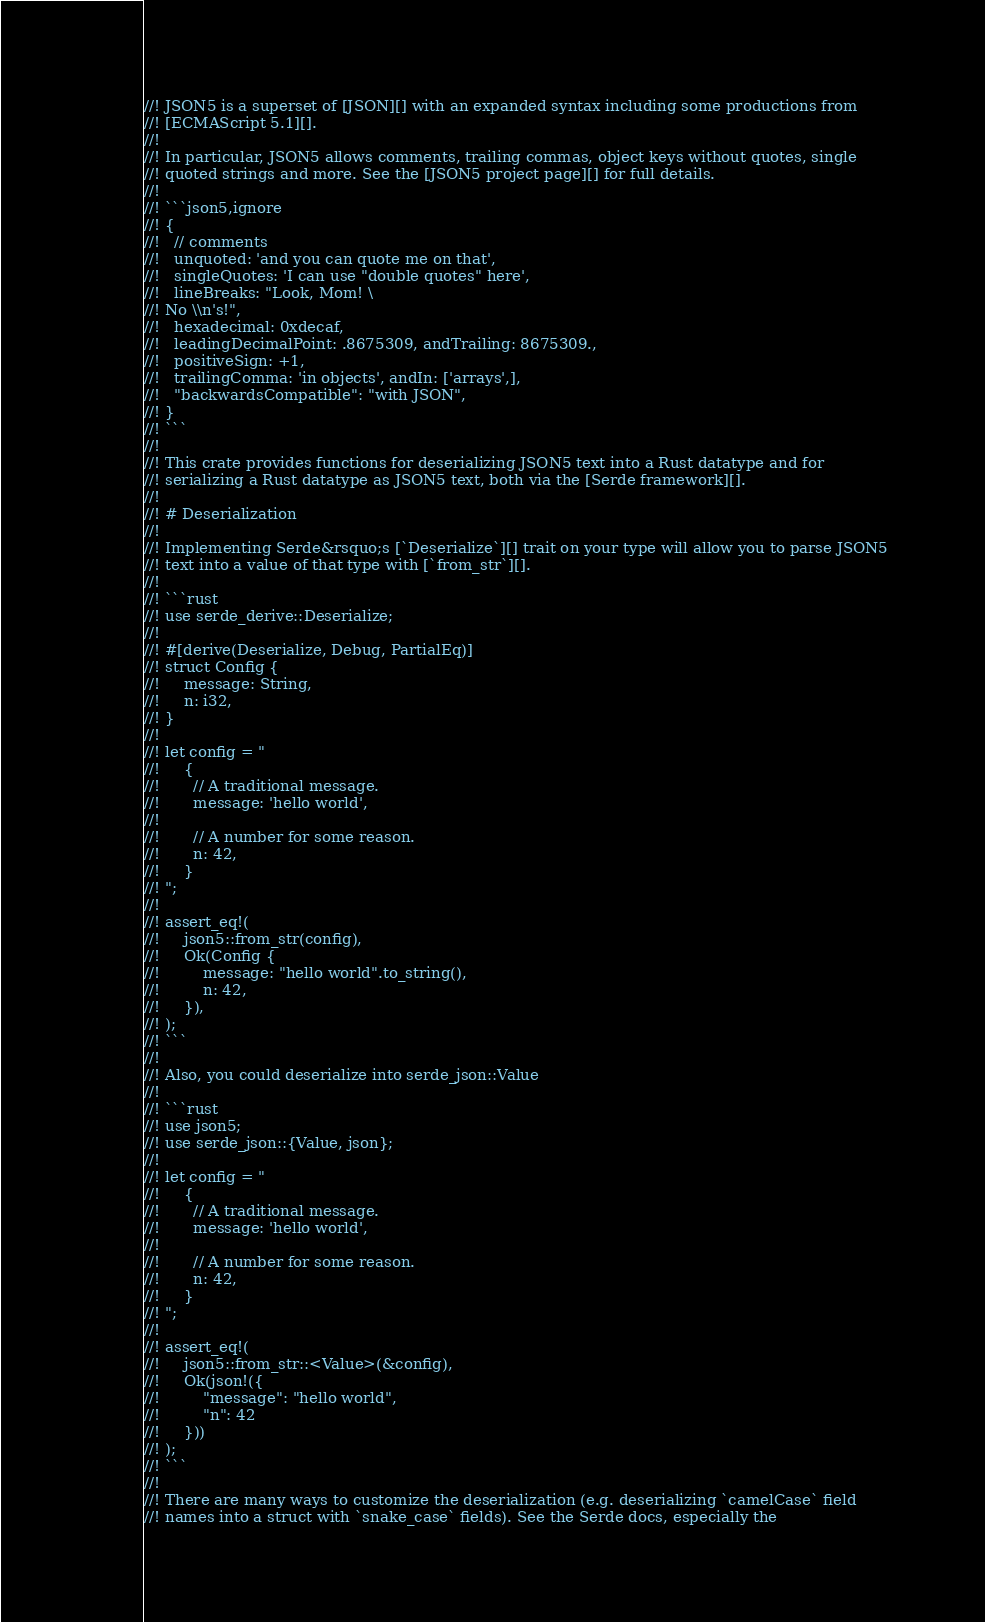Convert code to text. <code><loc_0><loc_0><loc_500><loc_500><_Rust_>//! JSON5 is a superset of [JSON][] with an expanded syntax including some productions from
//! [ECMAScript 5.1][].
//!
//! In particular, JSON5 allows comments, trailing commas, object keys without quotes, single
//! quoted strings and more. See the [JSON5 project page][] for full details.
//!
//! ```json5,ignore
//! {
//!   // comments
//!   unquoted: 'and you can quote me on that',
//!   singleQuotes: 'I can use "double quotes" here',
//!   lineBreaks: "Look, Mom! \
//! No \\n's!",
//!   hexadecimal: 0xdecaf,
//!   leadingDecimalPoint: .8675309, andTrailing: 8675309.,
//!   positiveSign: +1,
//!   trailingComma: 'in objects', andIn: ['arrays',],
//!   "backwardsCompatible": "with JSON",
//! }
//! ```
//!
//! This crate provides functions for deserializing JSON5 text into a Rust datatype and for
//! serializing a Rust datatype as JSON5 text, both via the [Serde framework][].
//!
//! # Deserialization
//!
//! Implementing Serde&rsquo;s [`Deserialize`][] trait on your type will allow you to parse JSON5
//! text into a value of that type with [`from_str`][].
//!
//! ```rust
//! use serde_derive::Deserialize;
//!
//! #[derive(Deserialize, Debug, PartialEq)]
//! struct Config {
//!     message: String,
//!     n: i32,
//! }
//!
//! let config = "
//!     {
//!       // A traditional message.
//!       message: 'hello world',
//!
//!       // A number for some reason.
//!       n: 42,
//!     }
//! ";
//!
//! assert_eq!(
//!     json5::from_str(config),
//!     Ok(Config {
//!         message: "hello world".to_string(),
//!         n: 42,
//!     }),
//! );
//! ```
//!
//! Also, you could deserialize into serde_json::Value
//!
//! ```rust
//! use json5;
//! use serde_json::{Value, json};
//!
//! let config = "
//!     {
//!       // A traditional message.
//!       message: 'hello world',
//!
//!       // A number for some reason.
//!       n: 42,
//!     }
//! ";
//!
//! assert_eq!(
//!     json5::from_str::<Value>(&config),
//!     Ok(json!({
//!         "message": "hello world",
//!         "n": 42
//!     }))
//! );
//! ```
//!
//! There are many ways to customize the deserialization (e.g. deserializing `camelCase` field
//! names into a struct with `snake_case` fields). See the Serde docs, especially the</code> 